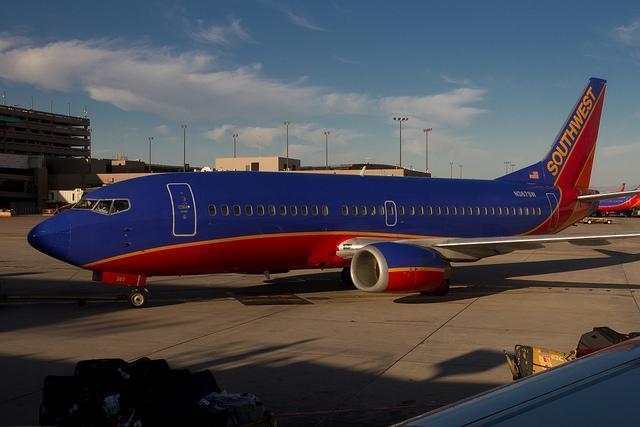How many cars are in the crosswalk?
Give a very brief answer. 0. 